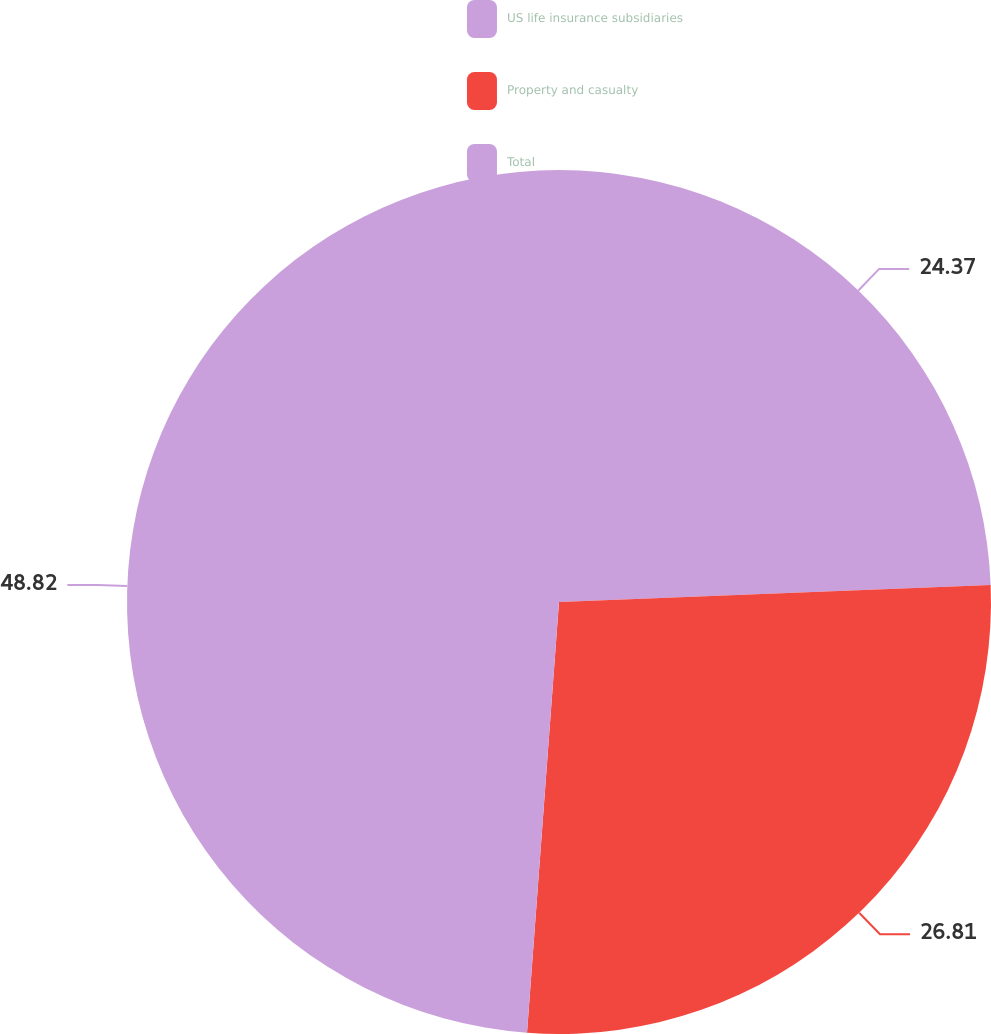Convert chart. <chart><loc_0><loc_0><loc_500><loc_500><pie_chart><fcel>US life insurance subsidiaries<fcel>Property and casualty<fcel>Total<nl><fcel>24.37%<fcel>26.81%<fcel>48.82%<nl></chart> 